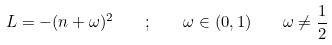<formula> <loc_0><loc_0><loc_500><loc_500>L = - ( n + \omega ) ^ { 2 } \quad ; \quad \omega \in ( 0 , 1 ) \quad \omega \neq \frac { 1 } { 2 }</formula> 